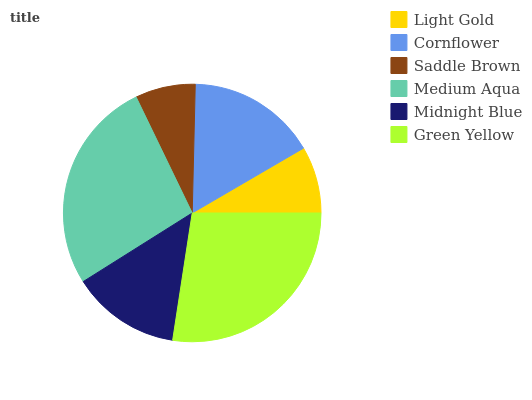Is Saddle Brown the minimum?
Answer yes or no. Yes. Is Green Yellow the maximum?
Answer yes or no. Yes. Is Cornflower the minimum?
Answer yes or no. No. Is Cornflower the maximum?
Answer yes or no. No. Is Cornflower greater than Light Gold?
Answer yes or no. Yes. Is Light Gold less than Cornflower?
Answer yes or no. Yes. Is Light Gold greater than Cornflower?
Answer yes or no. No. Is Cornflower less than Light Gold?
Answer yes or no. No. Is Cornflower the high median?
Answer yes or no. Yes. Is Midnight Blue the low median?
Answer yes or no. Yes. Is Midnight Blue the high median?
Answer yes or no. No. Is Saddle Brown the low median?
Answer yes or no. No. 